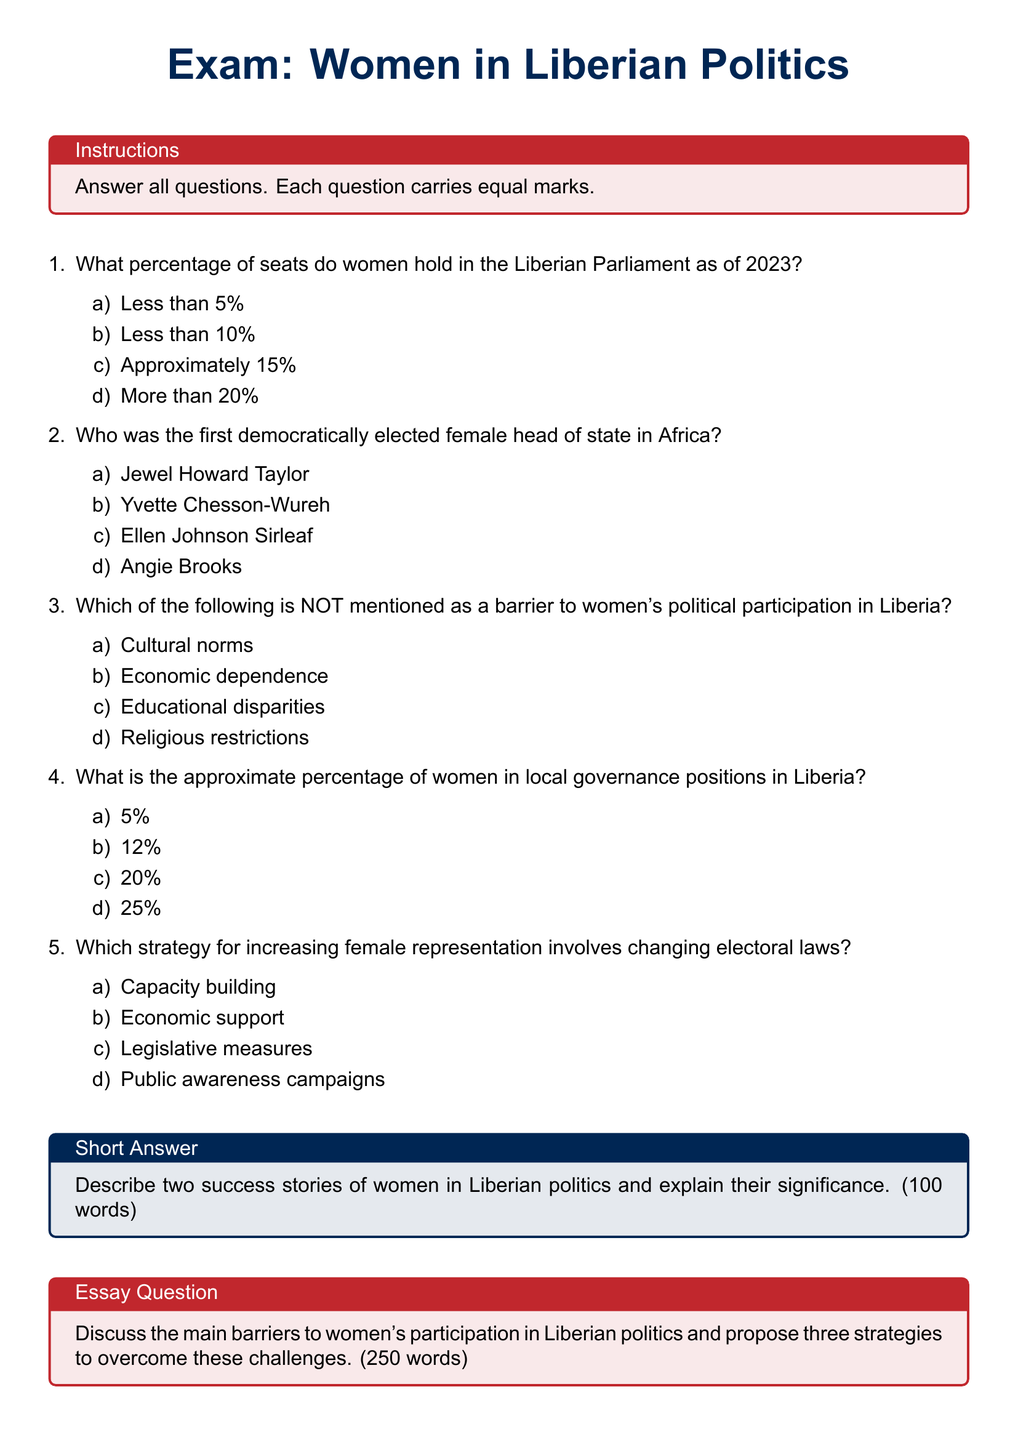What percentage of seats do women hold in the Liberian Parliament as of 2023? The document specifically asks for the percentage of seats held by women in the Liberian Parliament as of 2023.
Answer: Approximately 15% Who was the first democratically elected female head of state in Africa? The question refers to a prominent figure mentioned in the document related to women's political achievements in Africa.
Answer: Ellen Johnson Sirleaf Which of the following is NOT mentioned as a barrier to women's political participation in Liberia? This question tests knowledge on various barriers to women's participation listed in the document.
Answer: Religious restrictions What is the approximate percentage of women in local governance positions in Liberia? The document provides information regarding the representation of women in local governance positions.
Answer: 12% Which strategy for increasing female representation involves changing electoral laws? The document discusses various strategies to enhance women's representation, specifically asking about legislative measures.
Answer: Legislative measures Describe two success stories of women in Liberian politics and explain their significance. The question refers to the short answer section of the exam asking for success stories of women in politics.
Answer: N/A Discuss the main barriers to women's participation in Liberian politics and propose three strategies to overcome these challenges. This relates to the essay question section that explores barriers and strategies regarding women's political involvement.
Answer: N/A 